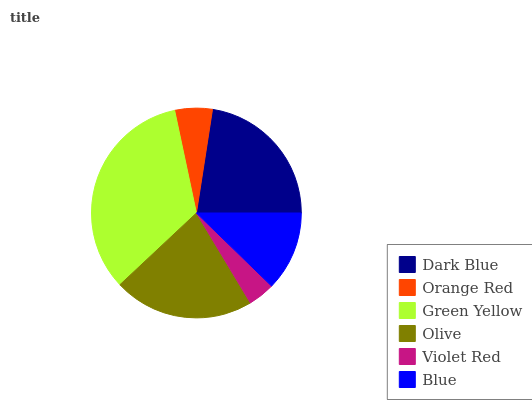Is Violet Red the minimum?
Answer yes or no. Yes. Is Green Yellow the maximum?
Answer yes or no. Yes. Is Orange Red the minimum?
Answer yes or no. No. Is Orange Red the maximum?
Answer yes or no. No. Is Dark Blue greater than Orange Red?
Answer yes or no. Yes. Is Orange Red less than Dark Blue?
Answer yes or no. Yes. Is Orange Red greater than Dark Blue?
Answer yes or no. No. Is Dark Blue less than Orange Red?
Answer yes or no. No. Is Olive the high median?
Answer yes or no. Yes. Is Blue the low median?
Answer yes or no. Yes. Is Orange Red the high median?
Answer yes or no. No. Is Orange Red the low median?
Answer yes or no. No. 